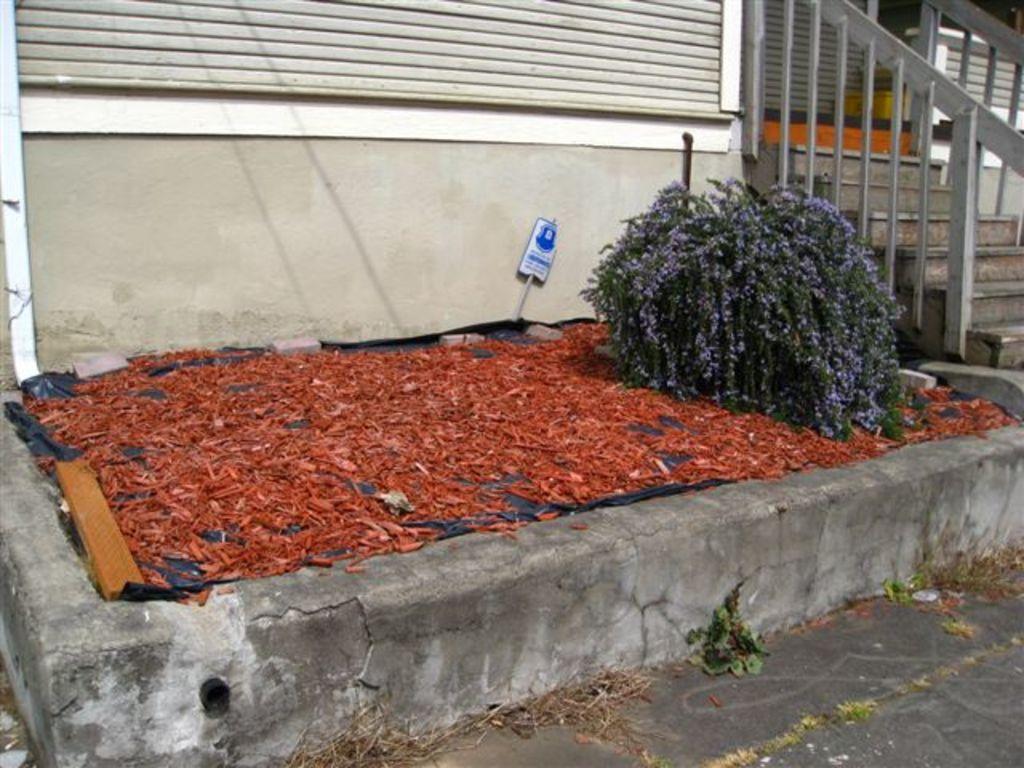Describe this image in one or two sentences. In this image, we can see some stairs and the railing. We can see a plant and some red colored objects. We can see the wall with some objects. We can see a poster and the ground with some objects. 